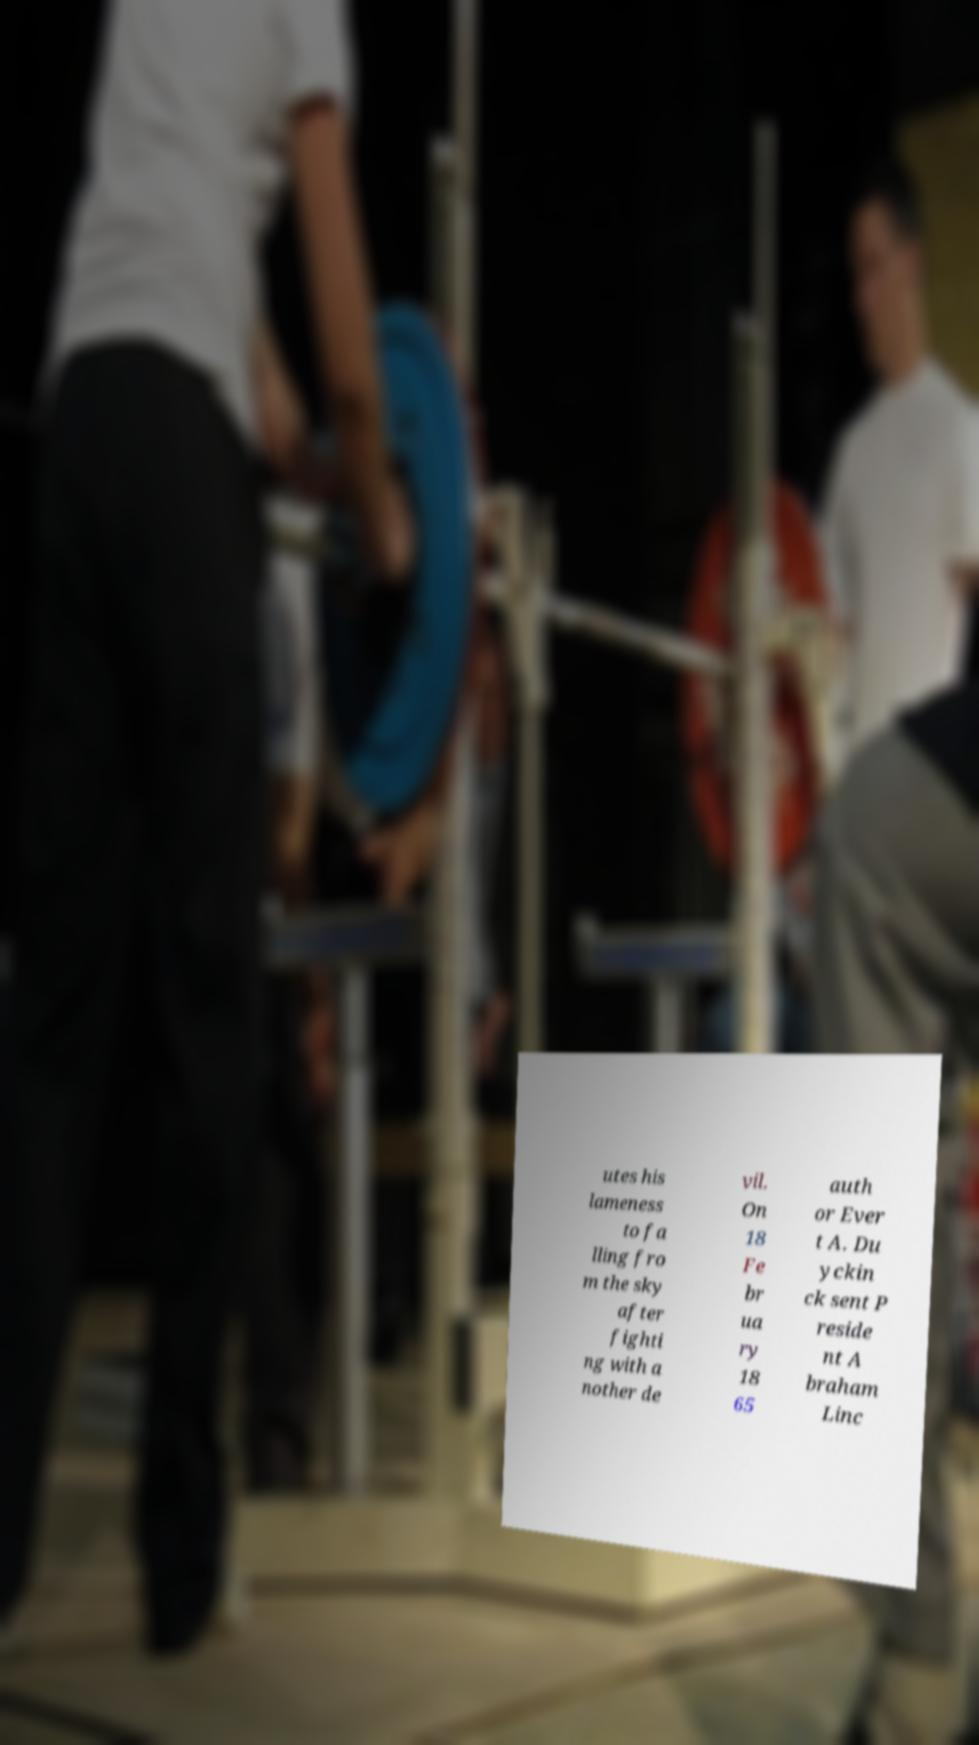Could you assist in decoding the text presented in this image and type it out clearly? utes his lameness to fa lling fro m the sky after fighti ng with a nother de vil. On 18 Fe br ua ry 18 65 auth or Ever t A. Du yckin ck sent P reside nt A braham Linc 